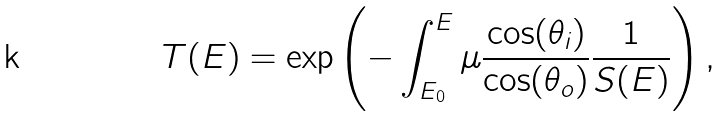Convert formula to latex. <formula><loc_0><loc_0><loc_500><loc_500>T ( E ) = \exp \left ( - \int _ { E _ { 0 } } ^ { E } \mu \frac { \cos ( \theta _ { i } ) } { \cos ( \theta _ { o } ) } \frac { 1 } { S ( E ) } \right ) ,</formula> 